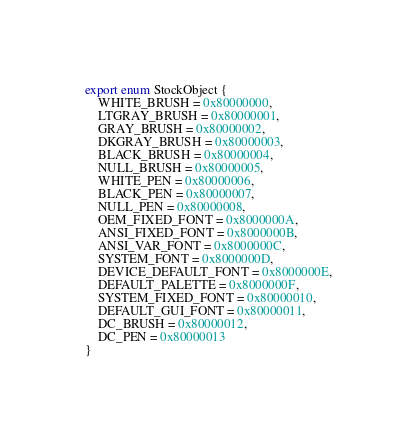<code> <loc_0><loc_0><loc_500><loc_500><_TypeScript_>export enum StockObject {
	WHITE_BRUSH = 0x80000000,
	LTGRAY_BRUSH = 0x80000001,
	GRAY_BRUSH = 0x80000002,
	DKGRAY_BRUSH = 0x80000003,
	BLACK_BRUSH = 0x80000004,
	NULL_BRUSH = 0x80000005,
	WHITE_PEN = 0x80000006,
	BLACK_PEN = 0x80000007,
	NULL_PEN = 0x80000008,
	OEM_FIXED_FONT = 0x8000000A,
	ANSI_FIXED_FONT = 0x8000000B,
	ANSI_VAR_FONT = 0x8000000C,
	SYSTEM_FONT = 0x8000000D,
	DEVICE_DEFAULT_FONT = 0x8000000E,
	DEFAULT_PALETTE = 0x8000000F,
	SYSTEM_FIXED_FONT = 0x80000010,
	DEFAULT_GUI_FONT = 0x80000011,
	DC_BRUSH = 0x80000012,
	DC_PEN = 0x80000013
}</code> 